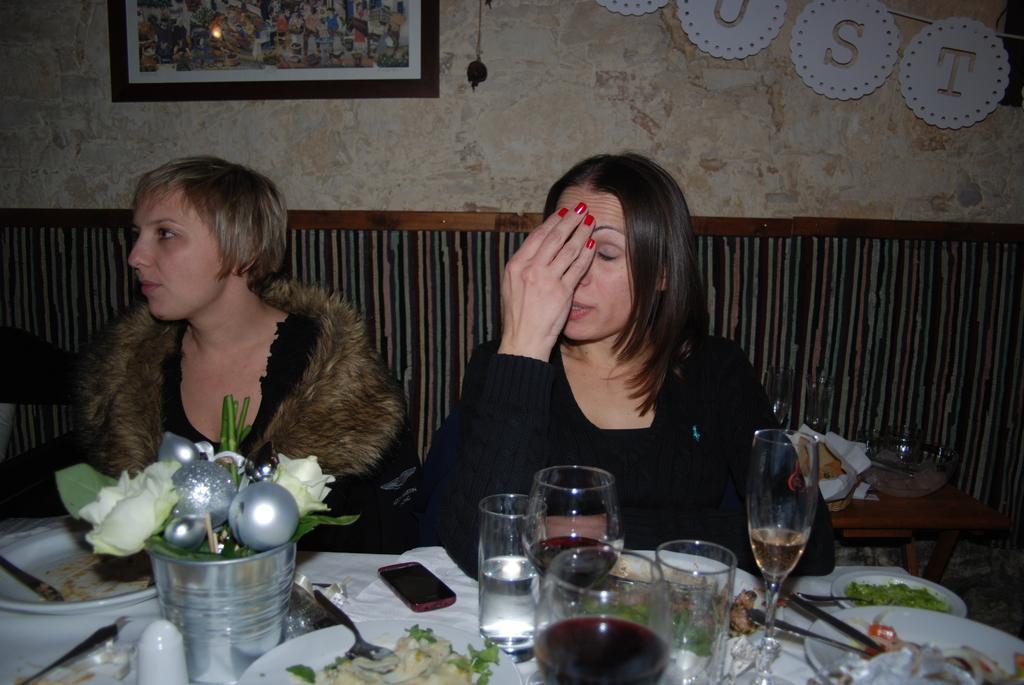Please provide a concise description of this image. In this image, we can see two womens are sitting. At the bottom, there is a table, covered with cloth. So many things and items are placed on it. Right side of the image, we can see a table, few objects are placed here. Background there is a wall. Top of the image, we can see a photo frame, some showpieces. Left side of the image, we can see some black color here. 